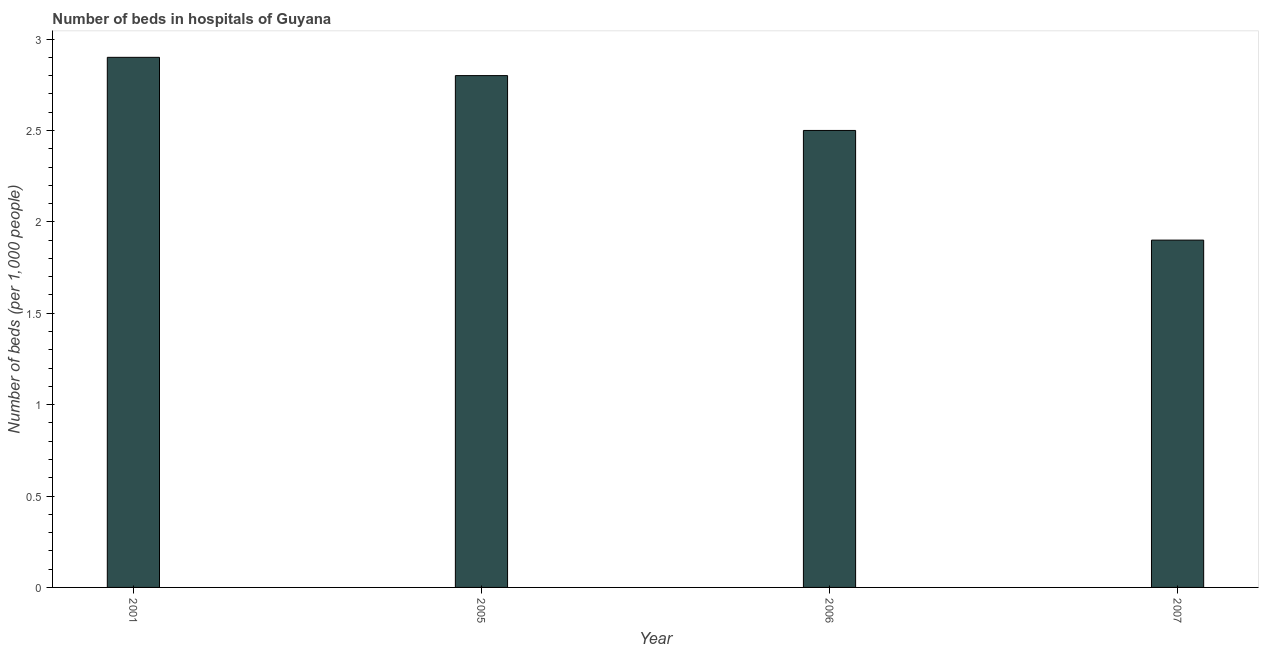Does the graph contain any zero values?
Keep it short and to the point. No. What is the title of the graph?
Offer a terse response. Number of beds in hospitals of Guyana. What is the label or title of the X-axis?
Your answer should be compact. Year. What is the label or title of the Y-axis?
Your answer should be very brief. Number of beds (per 1,0 people). In which year was the number of hospital beds minimum?
Give a very brief answer. 2007. What is the sum of the number of hospital beds?
Make the answer very short. 10.1. What is the average number of hospital beds per year?
Provide a succinct answer. 2.52. What is the median number of hospital beds?
Provide a succinct answer. 2.65. In how many years, is the number of hospital beds greater than 2.4 %?
Offer a very short reply. 3. What is the ratio of the number of hospital beds in 2001 to that in 2007?
Your answer should be very brief. 1.53. Is the number of hospital beds in 2005 less than that in 2007?
Keep it short and to the point. No. What is the difference between the highest and the second highest number of hospital beds?
Your answer should be very brief. 0.1. Is the sum of the number of hospital beds in 2006 and 2007 greater than the maximum number of hospital beds across all years?
Keep it short and to the point. Yes. In how many years, is the number of hospital beds greater than the average number of hospital beds taken over all years?
Make the answer very short. 2. How many bars are there?
Your answer should be very brief. 4. How many years are there in the graph?
Your answer should be very brief. 4. What is the difference between two consecutive major ticks on the Y-axis?
Keep it short and to the point. 0.5. What is the Number of beds (per 1,000 people) of 2007?
Give a very brief answer. 1.9. What is the difference between the Number of beds (per 1,000 people) in 2001 and 2006?
Provide a succinct answer. 0.4. What is the ratio of the Number of beds (per 1,000 people) in 2001 to that in 2005?
Provide a succinct answer. 1.04. What is the ratio of the Number of beds (per 1,000 people) in 2001 to that in 2006?
Make the answer very short. 1.16. What is the ratio of the Number of beds (per 1,000 people) in 2001 to that in 2007?
Provide a succinct answer. 1.53. What is the ratio of the Number of beds (per 1,000 people) in 2005 to that in 2006?
Your answer should be very brief. 1.12. What is the ratio of the Number of beds (per 1,000 people) in 2005 to that in 2007?
Offer a terse response. 1.47. What is the ratio of the Number of beds (per 1,000 people) in 2006 to that in 2007?
Keep it short and to the point. 1.32. 